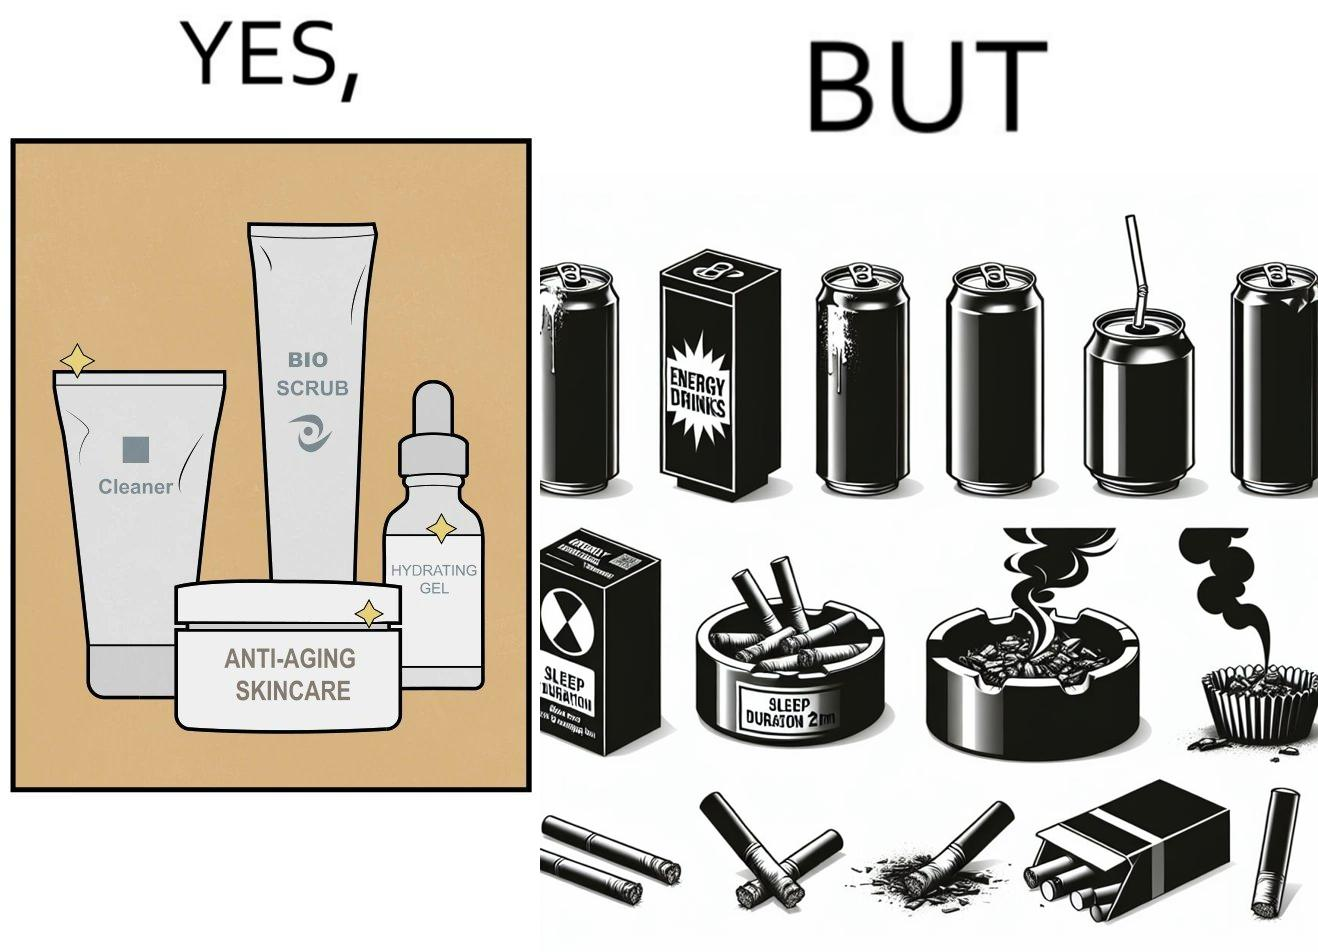What is shown in this image? This image is ironic as on the one hand, the presumed person is into skincare and wants to do the best for their skin, which is good, but on the other hand, they are involved in unhealthy habits that will damage their skin like smoking, caffeine and inadequate sleep. 